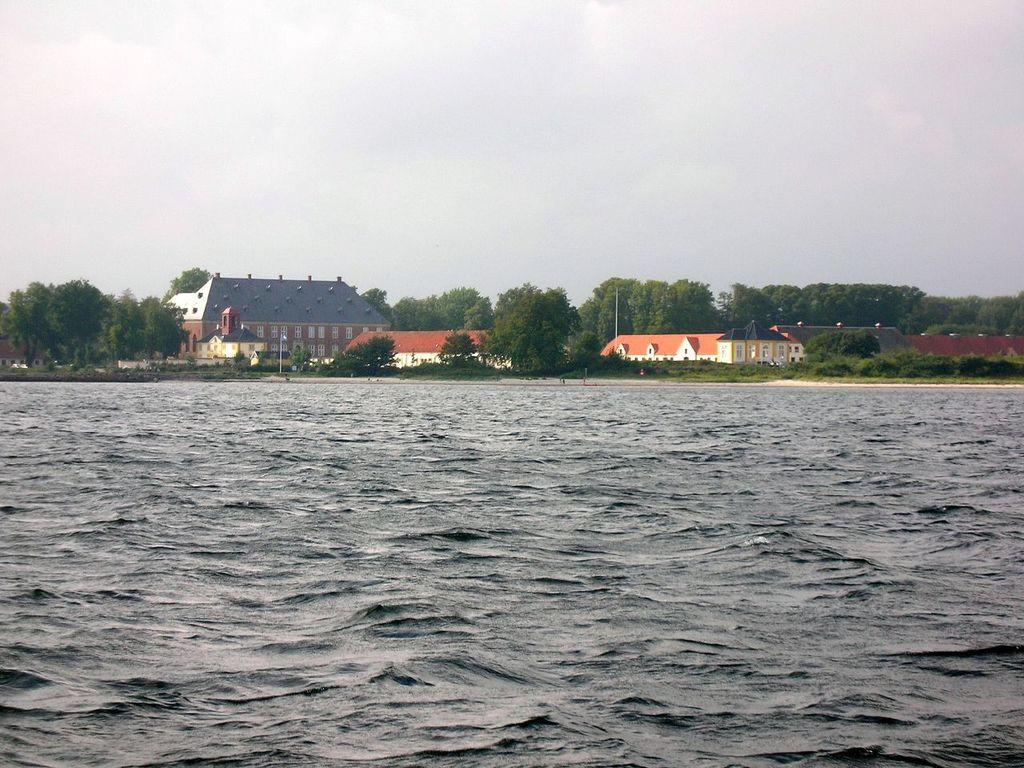What is the primary element in the image? There is water in the image. What structures are located near the water? There are houses beside the water. What type of vegetation is present in the image? There are trees in the image. What are the poles used for in the image? The purpose of the poles is not specified, but they are visible in the image. What else can be seen in the image besides the water, houses, trees, and poles? There are some objects in the image. What is visible in the background of the image? The sky is visible in the background of the image. How many clover leaves can be seen growing near the water in the image? There is no clover present in the image, so it is not possible to determine the number of leaves. 